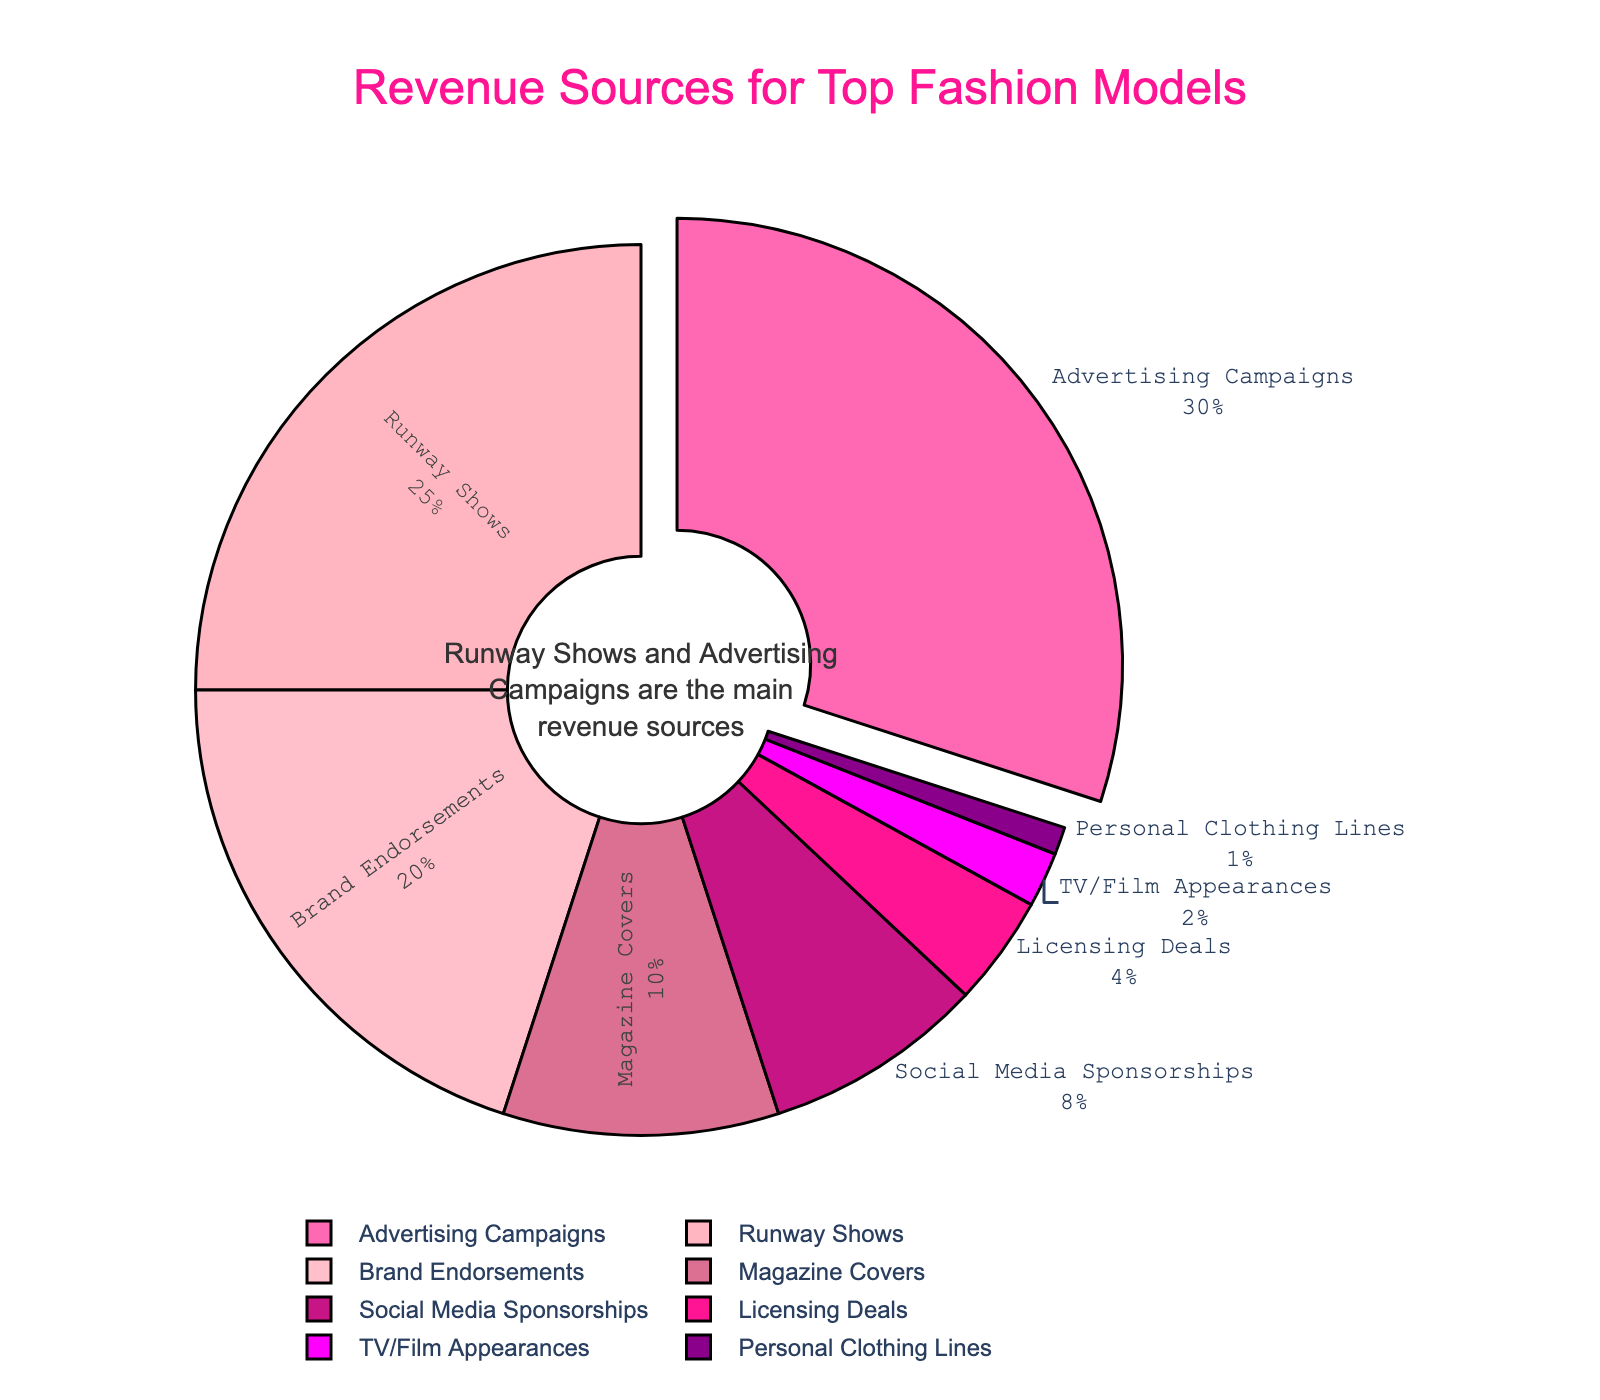What is the largest revenue source for top fashion models? The largest segment of the pie chart shows "Advertising Campaigns" with the highest percentage.
Answer: Advertising Campaigns How much percentage do Runway Shows and Brand Endorsements collectively contribute to the total revenue? Runway Shows contribute 25%, and Brand Endorsements contribute 20%. Summing them up gives 25% + 20% = 45%.
Answer: 45% Which category contributes more to the revenue, Magazine Covers or Social Media Sponsorships? Magazine Covers contribute 10%, and Social Media Sponsorships contribute 8%. Comparing these, Magazine Covers contribute more.
Answer: Magazine Covers By how much does the contribution of Advertising Campaigns exceed that of Runway Shows? Advertising Campaigns contribute 30%, and Runway Shows contribute 25%. The difference is 30% - 25% = 5%.
Answer: 5% What is the combined percentage of the sources that contribute less than 5% each? Licensing Deals contribute 4%, TV/Film Appearances contribute 2%, and Personal Clothing Lines contribute 1%. Summing these gives 4% + 2% + 1% = 7%.
Answer: 7% Which category is highlighted by being pulled out from the pie chart? The segment that is slightly separated from the rest is "Advertising Campaigns", which is visually pulled out.
Answer: Advertising Campaigns What is the visual significance of the color pink in the pie chart? Different shades of pink are used to distinguish between various categories in the chart. The different shades help in visually segmenting the revenue sources.
Answer: Distinguishes categories If Social Media Sponsorships' percentage was doubled, what would their new contribution be? The current contribution of Social Media Sponsorships is 8%. Doubling this would mean 8% * 2 = 16%.
Answer: 16% Which two categories have the smallest contributions to the revenue? The pie chart shows TV/Film Appearances at 2% and Personal Clothing Lines at 1%, making them the smallest contributors.
Answer: TV/Film Appearances and Personal Clothing Lines 